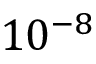Convert formula to latex. <formula><loc_0><loc_0><loc_500><loc_500>1 0 ^ { - 8 }</formula> 